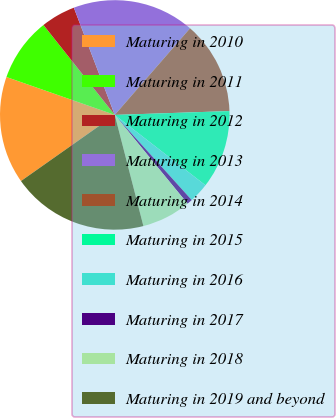<chart> <loc_0><loc_0><loc_500><loc_500><pie_chart><fcel>Maturing in 2010<fcel>Maturing in 2011<fcel>Maturing in 2012<fcel>Maturing in 2013<fcel>Maturing in 2014<fcel>Maturing in 2015<fcel>Maturing in 2016<fcel>Maturing in 2017<fcel>Maturing in 2018<fcel>Maturing in 2019 and beyond<nl><fcel>15.13%<fcel>8.97%<fcel>4.87%<fcel>17.19%<fcel>13.08%<fcel>11.03%<fcel>2.81%<fcel>0.76%<fcel>6.92%<fcel>19.24%<nl></chart> 